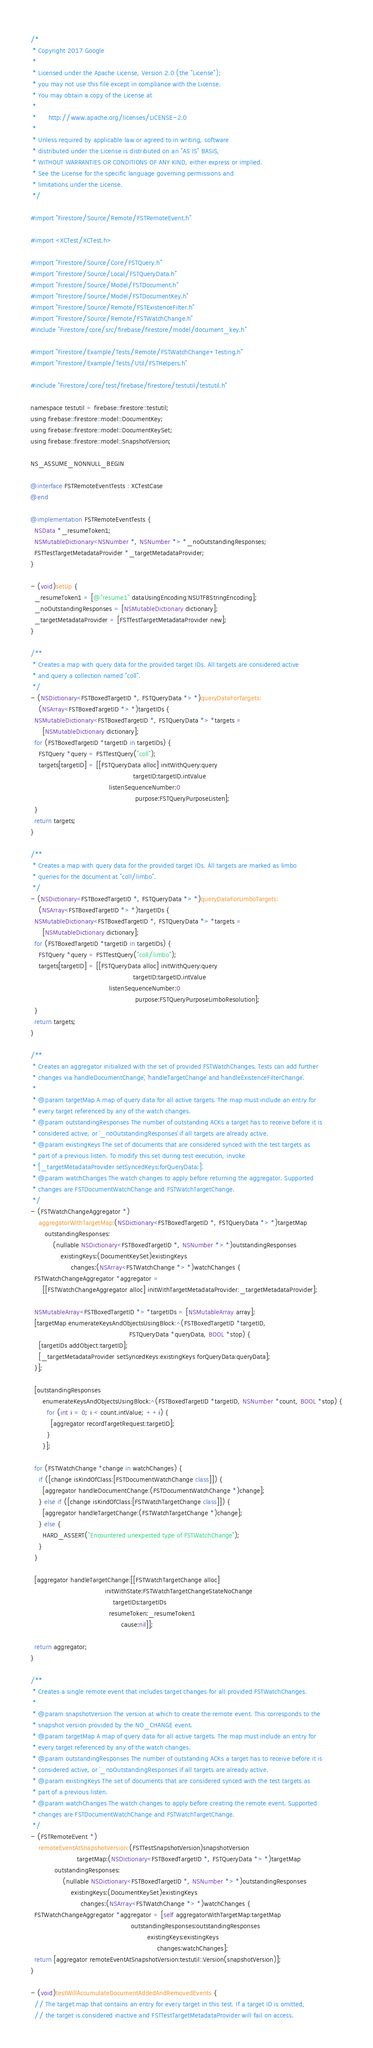Convert code to text. <code><loc_0><loc_0><loc_500><loc_500><_ObjectiveC_>/*
 * Copyright 2017 Google
 *
 * Licensed under the Apache License, Version 2.0 (the "License");
 * you may not use this file except in compliance with the License.
 * You may obtain a copy of the License at
 *
 *      http://www.apache.org/licenses/LICENSE-2.0
 *
 * Unless required by applicable law or agreed to in writing, software
 * distributed under the License is distributed on an "AS IS" BASIS,
 * WITHOUT WARRANTIES OR CONDITIONS OF ANY KIND, either express or implied.
 * See the License for the specific language governing permissions and
 * limitations under the License.
 */

#import "Firestore/Source/Remote/FSTRemoteEvent.h"

#import <XCTest/XCTest.h>

#import "Firestore/Source/Core/FSTQuery.h"
#import "Firestore/Source/Local/FSTQueryData.h"
#import "Firestore/Source/Model/FSTDocument.h"
#import "Firestore/Source/Model/FSTDocumentKey.h"
#import "Firestore/Source/Remote/FSTExistenceFilter.h"
#import "Firestore/Source/Remote/FSTWatchChange.h"
#include "Firestore/core/src/firebase/firestore/model/document_key.h"

#import "Firestore/Example/Tests/Remote/FSTWatchChange+Testing.h"
#import "Firestore/Example/Tests/Util/FSTHelpers.h"

#include "Firestore/core/test/firebase/firestore/testutil/testutil.h"

namespace testutil = firebase::firestore::testutil;
using firebase::firestore::model::DocumentKey;
using firebase::firestore::model::DocumentKeySet;
using firebase::firestore::model::SnapshotVersion;

NS_ASSUME_NONNULL_BEGIN

@interface FSTRemoteEventTests : XCTestCase
@end

@implementation FSTRemoteEventTests {
  NSData *_resumeToken1;
  NSMutableDictionary<NSNumber *, NSNumber *> *_noOutstandingResponses;
  FSTTestTargetMetadataProvider *_targetMetadataProvider;
}

- (void)setUp {
  _resumeToken1 = [@"resume1" dataUsingEncoding:NSUTF8StringEncoding];
  _noOutstandingResponses = [NSMutableDictionary dictionary];
  _targetMetadataProvider = [FSTTestTargetMetadataProvider new];
}

/**
 * Creates a map with query data for the provided target IDs. All targets are considered active
 * and query a collection named "coll".
 */
- (NSDictionary<FSTBoxedTargetID *, FSTQueryData *> *)queryDataForTargets:
    (NSArray<FSTBoxedTargetID *> *)targetIDs {
  NSMutableDictionary<FSTBoxedTargetID *, FSTQueryData *> *targets =
      [NSMutableDictionary dictionary];
  for (FSTBoxedTargetID *targetID in targetIDs) {
    FSTQuery *query = FSTTestQuery("coll");
    targets[targetID] = [[FSTQueryData alloc] initWithQuery:query
                                                   targetID:targetID.intValue
                                       listenSequenceNumber:0
                                                    purpose:FSTQueryPurposeListen];
  }
  return targets;
}

/**
 * Creates a map with query data for the provided target IDs. All targets are marked as limbo
 * queries for the document at "coll/limbo".
 */
- (NSDictionary<FSTBoxedTargetID *, FSTQueryData *> *)queryDataForLimboTargets:
    (NSArray<FSTBoxedTargetID *> *)targetIDs {
  NSMutableDictionary<FSTBoxedTargetID *, FSTQueryData *> *targets =
      [NSMutableDictionary dictionary];
  for (FSTBoxedTargetID *targetID in targetIDs) {
    FSTQuery *query = FSTTestQuery("coll/limbo");
    targets[targetID] = [[FSTQueryData alloc] initWithQuery:query
                                                   targetID:targetID.intValue
                                       listenSequenceNumber:0
                                                    purpose:FSTQueryPurposeLimboResolution];
  }
  return targets;
}

/**
 * Creates an aggregator initialized with the set of provided FSTWatchChanges. Tests can add further
 * changes via `handleDocumentChange`, `handleTargetChange` and `handleExistenceFilterChange`.
 *
 * @param targetMap A map of query data for all active targets. The map must include an entry for
 * every target referenced by any of the watch changes.
 * @param outstandingResponses The number of outstanding ACKs a target has to receive before it is
 * considered active, or `_noOutstandingResponses` if all targets are already active.
 * @param existingKeys The set of documents that are considered synced with the test targets as
 * part of a previous listen. To modify this set during test execution, invoke
 * `[_targetMetadataProvider setSyncedKeys:forQueryData:]`.
 * @param watchChanges The watch changes to apply before returning the aggregator. Supported
 * changes are FSTDocumentWatchChange and FSTWatchTargetChange.
 */
- (FSTWatchChangeAggregator *)
    aggregatorWithTargetMap:(NSDictionary<FSTBoxedTargetID *, FSTQueryData *> *)targetMap
       outstandingResponses:
           (nullable NSDictionary<FSTBoxedTargetID *, NSNumber *> *)outstandingResponses
               existingKeys:(DocumentKeySet)existingKeys
                    changes:(NSArray<FSTWatchChange *> *)watchChanges {
  FSTWatchChangeAggregator *aggregator =
      [[FSTWatchChangeAggregator alloc] initWithTargetMetadataProvider:_targetMetadataProvider];

  NSMutableArray<FSTBoxedTargetID *> *targetIDs = [NSMutableArray array];
  [targetMap enumerateKeysAndObjectsUsingBlock:^(FSTBoxedTargetID *targetID,
                                                 FSTQueryData *queryData, BOOL *stop) {
    [targetIDs addObject:targetID];
    [_targetMetadataProvider setSyncedKeys:existingKeys forQueryData:queryData];
  }];

  [outstandingResponses
      enumerateKeysAndObjectsUsingBlock:^(FSTBoxedTargetID *targetID, NSNumber *count, BOOL *stop) {
        for (int i = 0; i < count.intValue; ++i) {
          [aggregator recordTargetRequest:targetID];
        }
      }];

  for (FSTWatchChange *change in watchChanges) {
    if ([change isKindOfClass:[FSTDocumentWatchChange class]]) {
      [aggregator handleDocumentChange:(FSTDocumentWatchChange *)change];
    } else if ([change isKindOfClass:[FSTWatchTargetChange class]]) {
      [aggregator handleTargetChange:(FSTWatchTargetChange *)change];
    } else {
      HARD_ASSERT("Encountered unexpected type of FSTWatchChange");
    }
  }

  [aggregator handleTargetChange:[[FSTWatchTargetChange alloc]
                                     initWithState:FSTWatchTargetChangeStateNoChange
                                         targetIDs:targetIDs
                                       resumeToken:_resumeToken1
                                             cause:nil]];

  return aggregator;
}

/**
 * Creates a single remote event that includes target changes for all provided FSTWatchChanges.
 *
 * @param snapshotVersion The version at which to create the remote event. This corresponds to the
 * snapshot version provided by the NO_CHANGE event.
 * @param targetMap A map of query data for all active targets. The map must include an entry for
 * every target referenced by any of the watch changes.
 * @param outstandingResponses The number of outstanding ACKs a target has to receive before it is
 * considered active, or `_noOutstandingResponses` if all targets are already active.
 * @param existingKeys The set of documents that are considered synced with the test targets as
 * part of a previous listen.
 * @param watchChanges The watch changes to apply before creating the remote event. Supported
 * changes are FSTDocumentWatchChange and FSTWatchTargetChange.
 */
- (FSTRemoteEvent *)
    remoteEventAtSnapshotVersion:(FSTTestSnapshotVersion)snapshotVersion
                       targetMap:(NSDictionary<FSTBoxedTargetID *, FSTQueryData *> *)targetMap
            outstandingResponses:
                (nullable NSDictionary<FSTBoxedTargetID *, NSNumber *> *)outstandingResponses
                    existingKeys:(DocumentKeySet)existingKeys
                         changes:(NSArray<FSTWatchChange *> *)watchChanges {
  FSTWatchChangeAggregator *aggregator = [self aggregatorWithTargetMap:targetMap
                                                  outstandingResponses:outstandingResponses
                                                          existingKeys:existingKeys
                                                               changes:watchChanges];
  return [aggregator remoteEventAtSnapshotVersion:testutil::Version(snapshotVersion)];
}

- (void)testWillAccumulateDocumentAddedAndRemovedEvents {
  // The target map that contains an entry for every target in this test. If a target ID is omitted,
  // the target is considered inactive and FSTTestTargetMetadataProvider will fail on access.</code> 